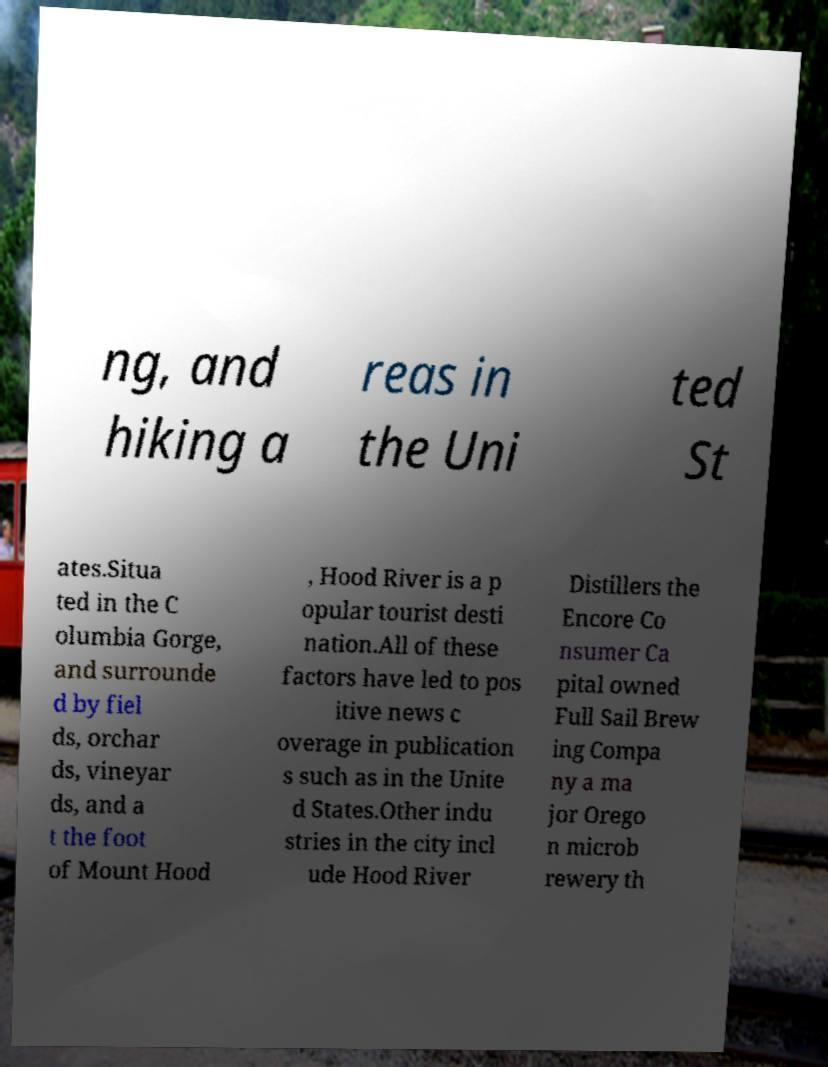Can you read and provide the text displayed in the image?This photo seems to have some interesting text. Can you extract and type it out for me? ng, and hiking a reas in the Uni ted St ates.Situa ted in the C olumbia Gorge, and surrounde d by fiel ds, orchar ds, vineyar ds, and a t the foot of Mount Hood , Hood River is a p opular tourist desti nation.All of these factors have led to pos itive news c overage in publication s such as in the Unite d States.Other indu stries in the city incl ude Hood River Distillers the Encore Co nsumer Ca pital owned Full Sail Brew ing Compa ny a ma jor Orego n microb rewery th 